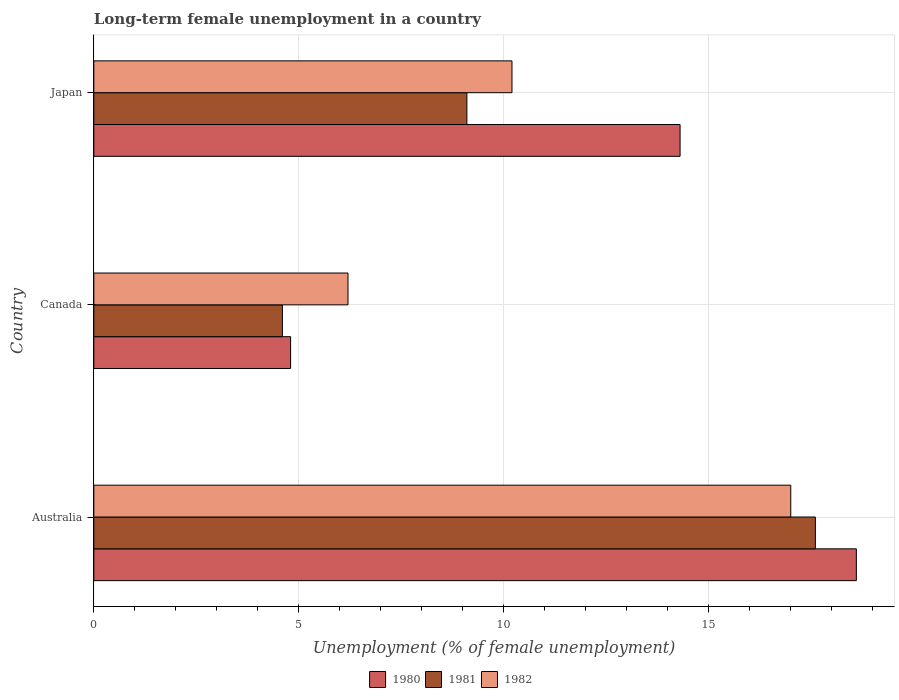How many different coloured bars are there?
Ensure brevity in your answer.  3. Are the number of bars per tick equal to the number of legend labels?
Your answer should be very brief. Yes. How many bars are there on the 3rd tick from the top?
Offer a terse response. 3. What is the percentage of long-term unemployed female population in 1980 in Japan?
Provide a succinct answer. 14.3. Across all countries, what is the maximum percentage of long-term unemployed female population in 1980?
Your answer should be very brief. 18.6. Across all countries, what is the minimum percentage of long-term unemployed female population in 1982?
Make the answer very short. 6.2. In which country was the percentage of long-term unemployed female population in 1982 maximum?
Provide a succinct answer. Australia. In which country was the percentage of long-term unemployed female population in 1981 minimum?
Your answer should be compact. Canada. What is the total percentage of long-term unemployed female population in 1982 in the graph?
Provide a succinct answer. 33.4. What is the difference between the percentage of long-term unemployed female population in 1980 in Canada and that in Japan?
Your response must be concise. -9.5. What is the difference between the percentage of long-term unemployed female population in 1980 in Japan and the percentage of long-term unemployed female population in 1981 in Canada?
Give a very brief answer. 9.7. What is the average percentage of long-term unemployed female population in 1981 per country?
Ensure brevity in your answer.  10.43. What is the difference between the percentage of long-term unemployed female population in 1980 and percentage of long-term unemployed female population in 1981 in Australia?
Provide a short and direct response. 1. In how many countries, is the percentage of long-term unemployed female population in 1981 greater than 15 %?
Make the answer very short. 1. What is the ratio of the percentage of long-term unemployed female population in 1981 in Canada to that in Japan?
Your answer should be compact. 0.51. Is the percentage of long-term unemployed female population in 1981 in Australia less than that in Canada?
Give a very brief answer. No. Is the difference between the percentage of long-term unemployed female population in 1980 in Australia and Japan greater than the difference between the percentage of long-term unemployed female population in 1981 in Australia and Japan?
Provide a succinct answer. No. What is the difference between the highest and the second highest percentage of long-term unemployed female population in 1980?
Your response must be concise. 4.3. What is the difference between the highest and the lowest percentage of long-term unemployed female population in 1981?
Ensure brevity in your answer.  13. In how many countries, is the percentage of long-term unemployed female population in 1981 greater than the average percentage of long-term unemployed female population in 1981 taken over all countries?
Your response must be concise. 1. Is it the case that in every country, the sum of the percentage of long-term unemployed female population in 1982 and percentage of long-term unemployed female population in 1980 is greater than the percentage of long-term unemployed female population in 1981?
Make the answer very short. Yes. Are all the bars in the graph horizontal?
Your response must be concise. Yes. How many countries are there in the graph?
Offer a very short reply. 3. Are the values on the major ticks of X-axis written in scientific E-notation?
Provide a short and direct response. No. Does the graph contain grids?
Offer a terse response. Yes. What is the title of the graph?
Your answer should be compact. Long-term female unemployment in a country. Does "2011" appear as one of the legend labels in the graph?
Your answer should be very brief. No. What is the label or title of the X-axis?
Your answer should be compact. Unemployment (% of female unemployment). What is the Unemployment (% of female unemployment) in 1980 in Australia?
Make the answer very short. 18.6. What is the Unemployment (% of female unemployment) in 1981 in Australia?
Offer a very short reply. 17.6. What is the Unemployment (% of female unemployment) in 1980 in Canada?
Offer a very short reply. 4.8. What is the Unemployment (% of female unemployment) of 1981 in Canada?
Provide a short and direct response. 4.6. What is the Unemployment (% of female unemployment) of 1982 in Canada?
Keep it short and to the point. 6.2. What is the Unemployment (% of female unemployment) of 1980 in Japan?
Give a very brief answer. 14.3. What is the Unemployment (% of female unemployment) in 1981 in Japan?
Provide a succinct answer. 9.1. What is the Unemployment (% of female unemployment) of 1982 in Japan?
Ensure brevity in your answer.  10.2. Across all countries, what is the maximum Unemployment (% of female unemployment) of 1980?
Give a very brief answer. 18.6. Across all countries, what is the maximum Unemployment (% of female unemployment) in 1981?
Provide a succinct answer. 17.6. Across all countries, what is the maximum Unemployment (% of female unemployment) in 1982?
Ensure brevity in your answer.  17. Across all countries, what is the minimum Unemployment (% of female unemployment) of 1980?
Keep it short and to the point. 4.8. Across all countries, what is the minimum Unemployment (% of female unemployment) in 1981?
Offer a terse response. 4.6. Across all countries, what is the minimum Unemployment (% of female unemployment) of 1982?
Your response must be concise. 6.2. What is the total Unemployment (% of female unemployment) in 1980 in the graph?
Give a very brief answer. 37.7. What is the total Unemployment (% of female unemployment) of 1981 in the graph?
Keep it short and to the point. 31.3. What is the total Unemployment (% of female unemployment) of 1982 in the graph?
Keep it short and to the point. 33.4. What is the difference between the Unemployment (% of female unemployment) of 1981 in Australia and that in Canada?
Provide a short and direct response. 13. What is the difference between the Unemployment (% of female unemployment) in 1981 in Australia and that in Japan?
Give a very brief answer. 8.5. What is the difference between the Unemployment (% of female unemployment) of 1982 in Australia and that in Japan?
Keep it short and to the point. 6.8. What is the difference between the Unemployment (% of female unemployment) of 1980 in Canada and that in Japan?
Provide a succinct answer. -9.5. What is the difference between the Unemployment (% of female unemployment) in 1982 in Canada and that in Japan?
Keep it short and to the point. -4. What is the difference between the Unemployment (% of female unemployment) in 1981 in Australia and the Unemployment (% of female unemployment) in 1982 in Canada?
Your answer should be very brief. 11.4. What is the difference between the Unemployment (% of female unemployment) in 1980 in Australia and the Unemployment (% of female unemployment) in 1982 in Japan?
Provide a short and direct response. 8.4. What is the difference between the Unemployment (% of female unemployment) in 1981 in Australia and the Unemployment (% of female unemployment) in 1982 in Japan?
Offer a very short reply. 7.4. What is the difference between the Unemployment (% of female unemployment) in 1980 in Canada and the Unemployment (% of female unemployment) in 1982 in Japan?
Offer a very short reply. -5.4. What is the average Unemployment (% of female unemployment) in 1980 per country?
Offer a very short reply. 12.57. What is the average Unemployment (% of female unemployment) of 1981 per country?
Ensure brevity in your answer.  10.43. What is the average Unemployment (% of female unemployment) of 1982 per country?
Give a very brief answer. 11.13. What is the difference between the Unemployment (% of female unemployment) in 1980 and Unemployment (% of female unemployment) in 1981 in Australia?
Your answer should be very brief. 1. What is the difference between the Unemployment (% of female unemployment) of 1981 and Unemployment (% of female unemployment) of 1982 in Australia?
Provide a succinct answer. 0.6. What is the difference between the Unemployment (% of female unemployment) in 1980 and Unemployment (% of female unemployment) in 1982 in Japan?
Offer a terse response. 4.1. What is the difference between the Unemployment (% of female unemployment) of 1981 and Unemployment (% of female unemployment) of 1982 in Japan?
Provide a succinct answer. -1.1. What is the ratio of the Unemployment (% of female unemployment) of 1980 in Australia to that in Canada?
Your response must be concise. 3.88. What is the ratio of the Unemployment (% of female unemployment) in 1981 in Australia to that in Canada?
Provide a short and direct response. 3.83. What is the ratio of the Unemployment (% of female unemployment) of 1982 in Australia to that in Canada?
Offer a terse response. 2.74. What is the ratio of the Unemployment (% of female unemployment) in 1980 in Australia to that in Japan?
Ensure brevity in your answer.  1.3. What is the ratio of the Unemployment (% of female unemployment) in 1981 in Australia to that in Japan?
Keep it short and to the point. 1.93. What is the ratio of the Unemployment (% of female unemployment) in 1980 in Canada to that in Japan?
Ensure brevity in your answer.  0.34. What is the ratio of the Unemployment (% of female unemployment) in 1981 in Canada to that in Japan?
Keep it short and to the point. 0.51. What is the ratio of the Unemployment (% of female unemployment) in 1982 in Canada to that in Japan?
Ensure brevity in your answer.  0.61. What is the difference between the highest and the second highest Unemployment (% of female unemployment) in 1980?
Your answer should be very brief. 4.3. What is the difference between the highest and the lowest Unemployment (% of female unemployment) of 1980?
Ensure brevity in your answer.  13.8. What is the difference between the highest and the lowest Unemployment (% of female unemployment) in 1982?
Give a very brief answer. 10.8. 